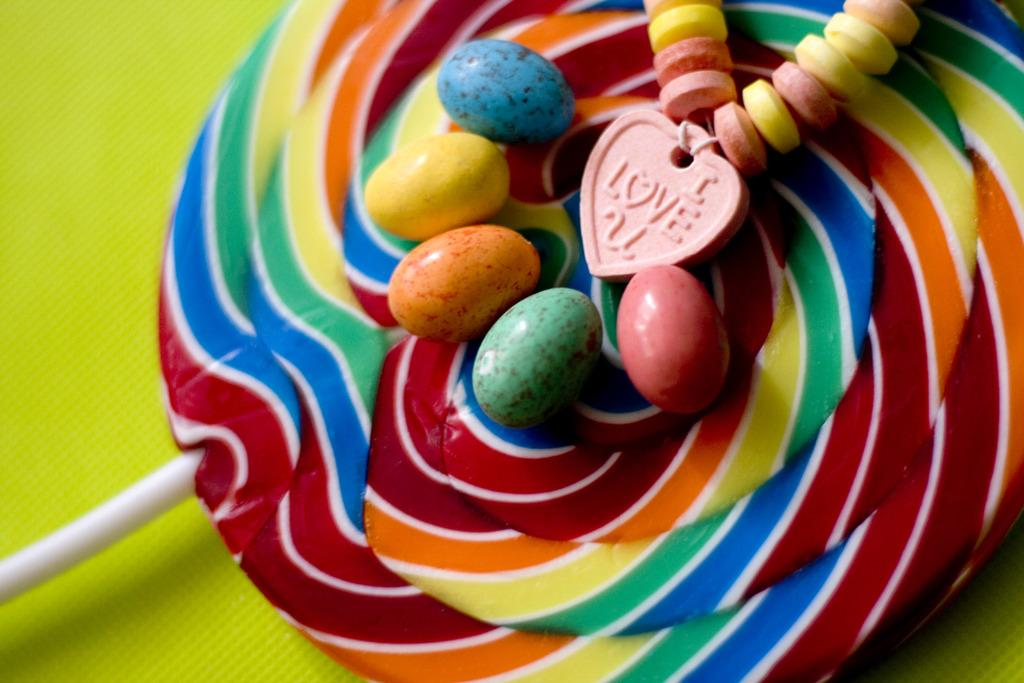What type of sweets can be seen in the image? There are candies in the image. What other type of sweet is present in the image? There is a lollipop in the image. How many secretaries are present at the feast in the image? There is no feast or secretary present in the image; it only features candies and a lollipop. What type of hat is being worn by the candies in the image? There are no hats present in the image, as candies do not wear hats. 